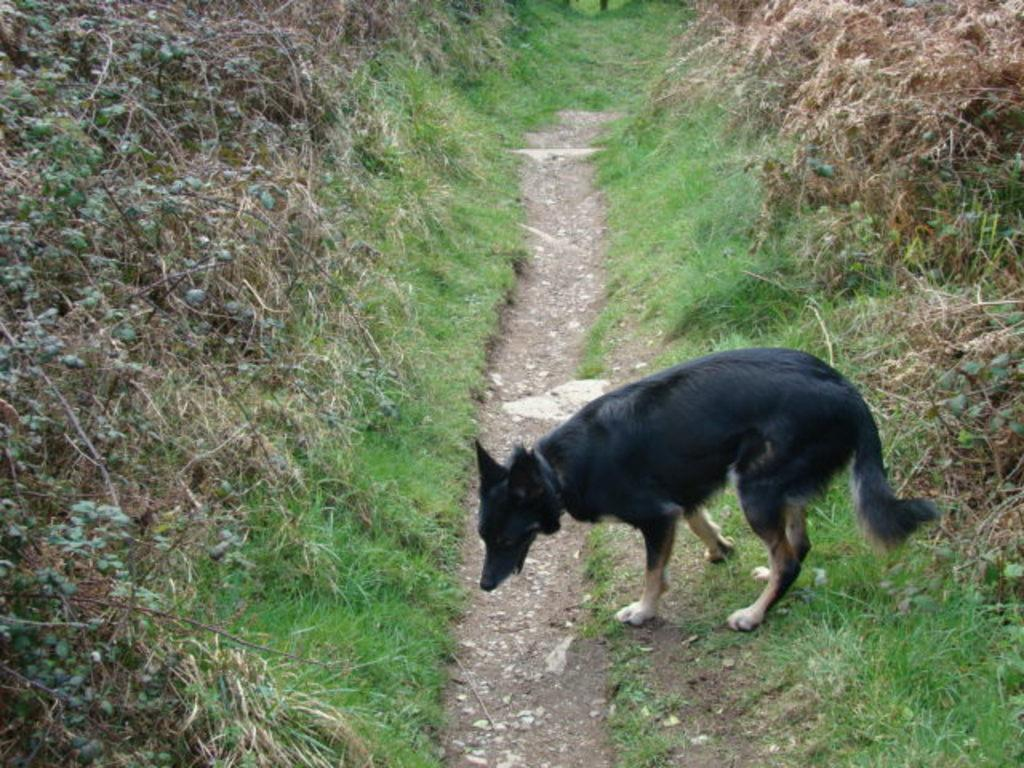What type of animal is in the picture? There is a black color dog in the picture. Where is the dog positioned in relation to the grass? The dog is standing near to the grass. How does the grass appear in the picture? The grass is dry. What type of cap is the dog wearing in the picture? There is no cap present in the image; the dog is not wearing any clothing or accessories. 